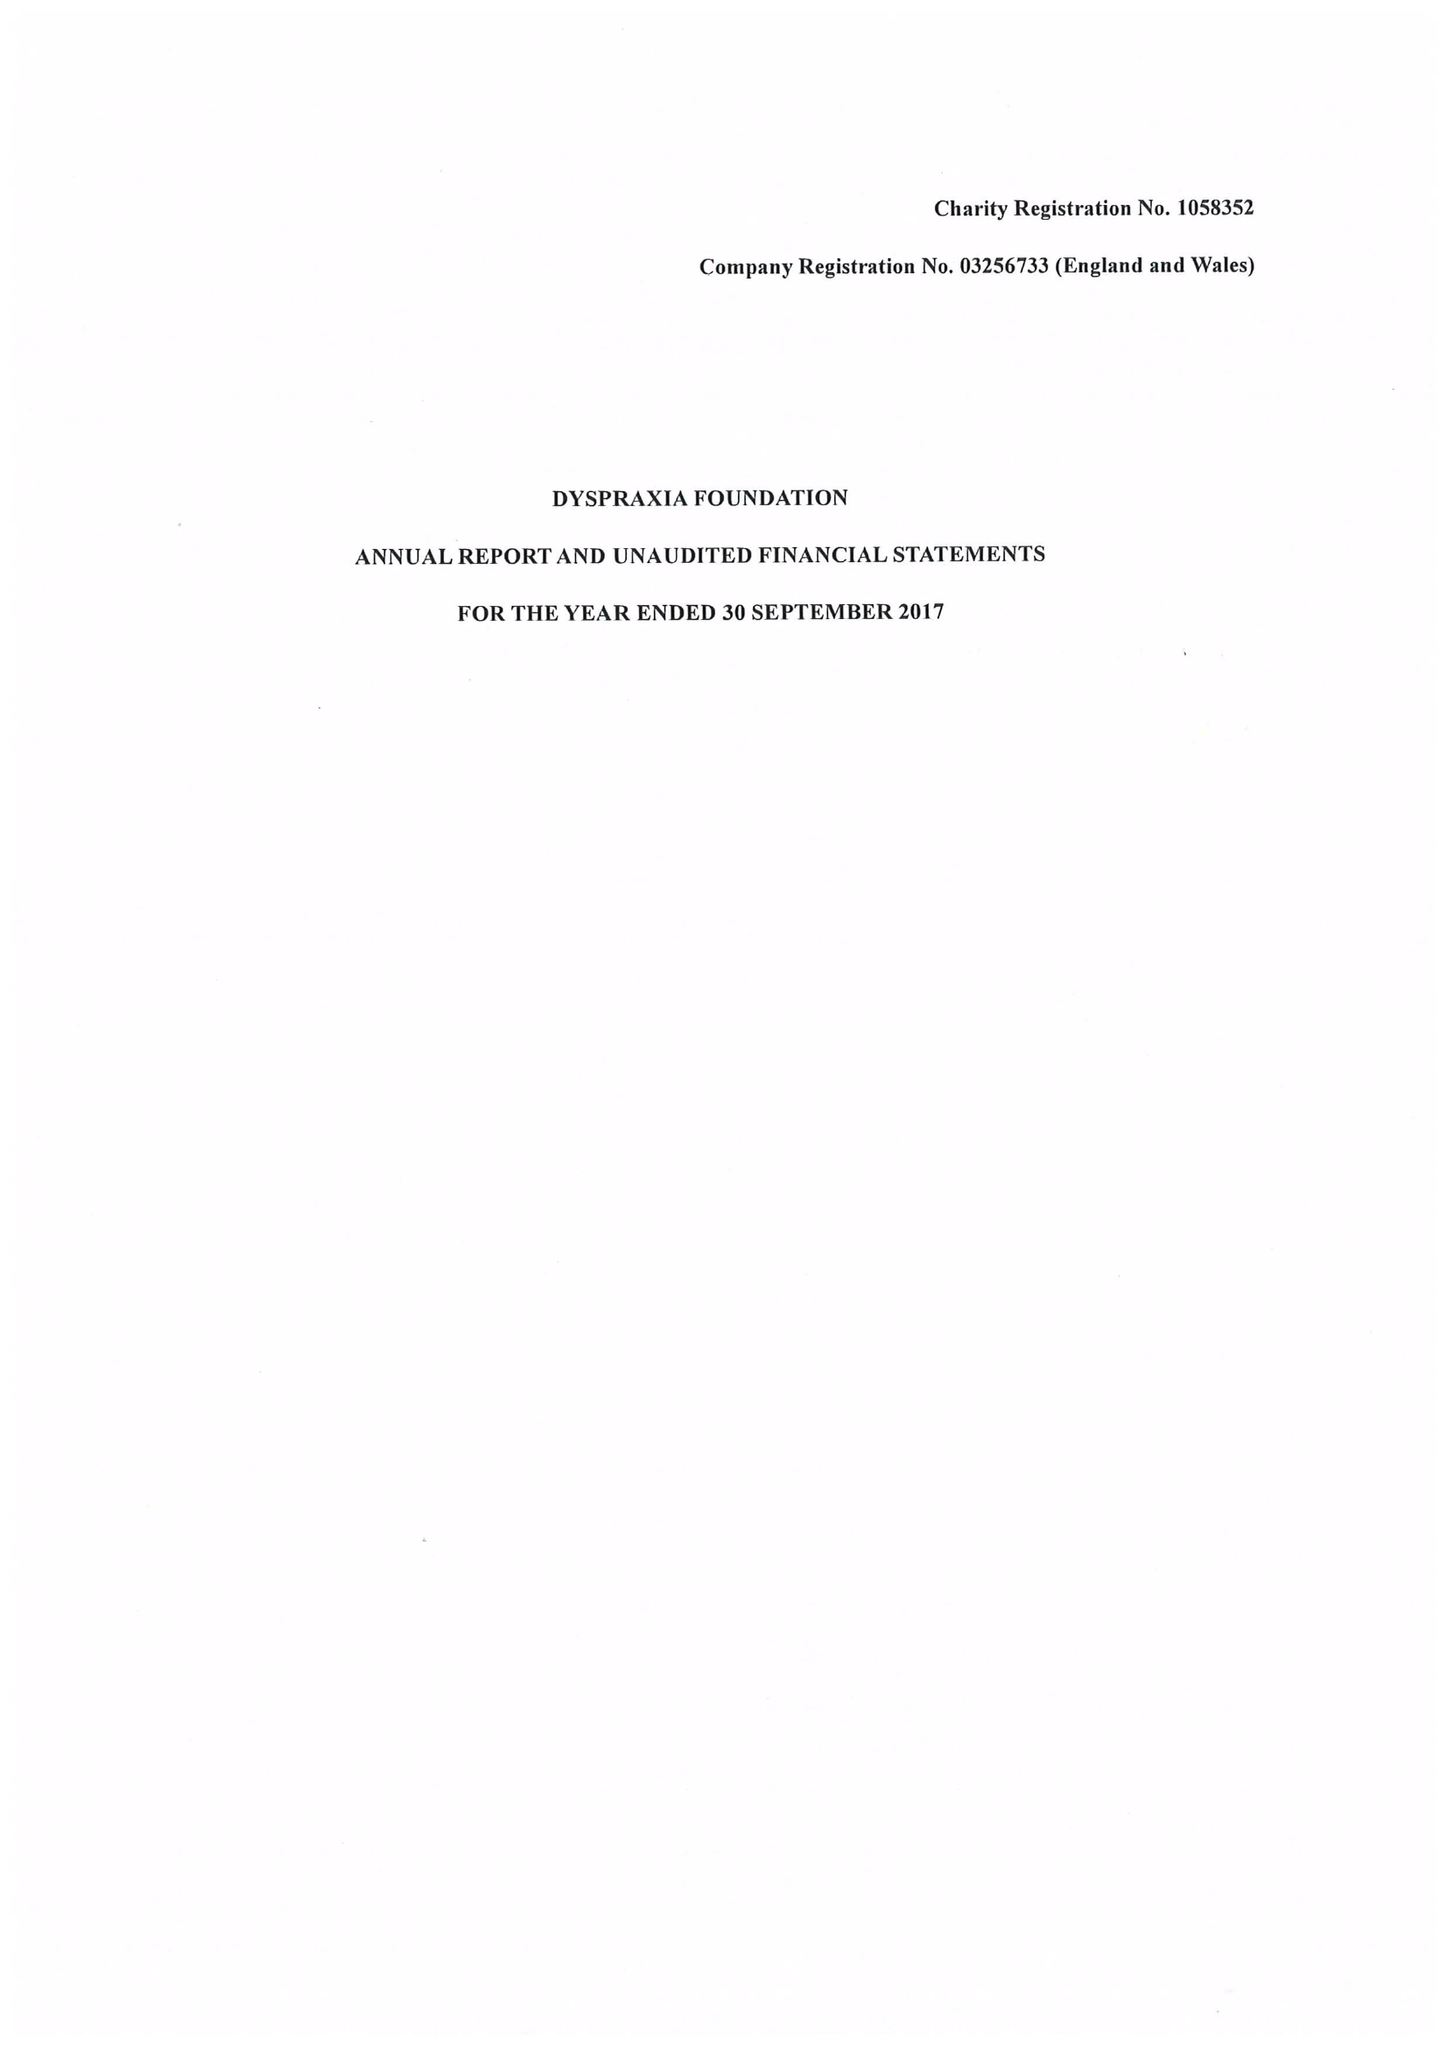What is the value for the income_annually_in_british_pounds?
Answer the question using a single word or phrase. 193264.00 